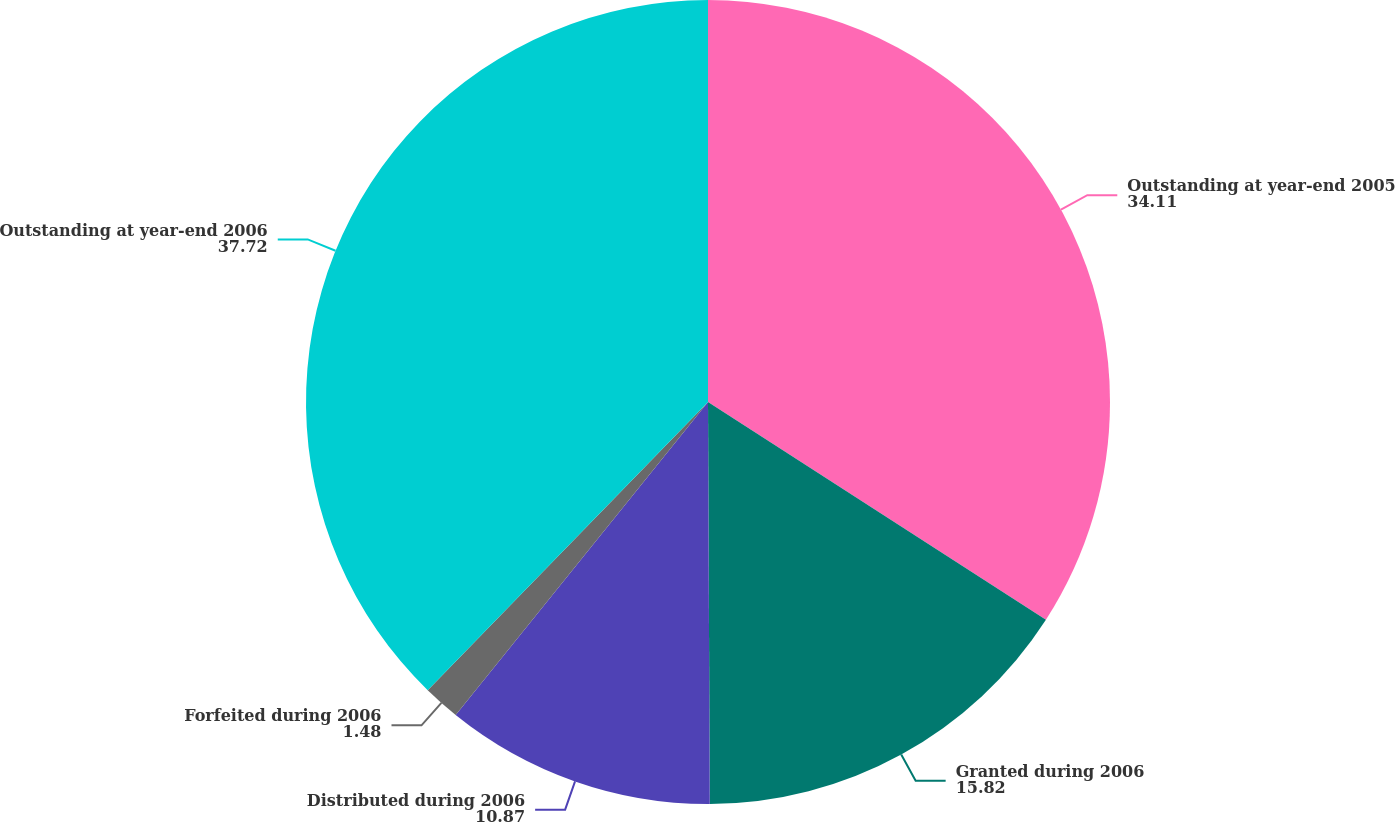Convert chart. <chart><loc_0><loc_0><loc_500><loc_500><pie_chart><fcel>Outstanding at year-end 2005<fcel>Granted during 2006<fcel>Distributed during 2006<fcel>Forfeited during 2006<fcel>Outstanding at year-end 2006<nl><fcel>34.11%<fcel>15.82%<fcel>10.87%<fcel>1.48%<fcel>37.72%<nl></chart> 